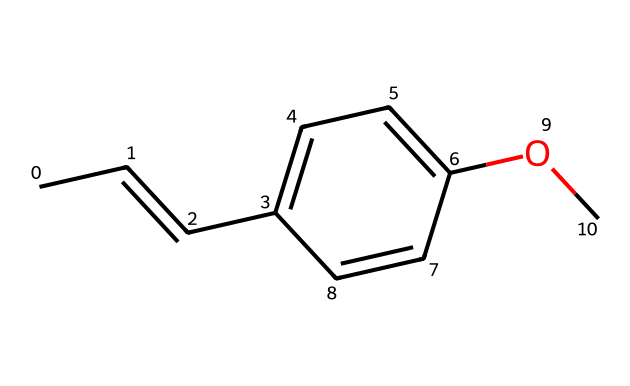What is the molecular formula of this compound? To determine the molecular formula, count the number of each type of atom in the structure. In this SMILES representation, there are 10 carbon atoms (C), 12 hydrogen atoms (H), and 1 oxygen atom (O). This gives the formula C10H12O.
Answer: C10H12O How many double bonds are present in this structure? Examine the SMILES; the "CC=CC" part indicates one double bond, and "C1=CC=C" presents two further double bonds in the ring. In total, there are three double bonds in the structure.
Answer: 3 Which type of isomerism is displayed in this compound? The presence of cis and trans configurations around the double bonds indicates geometric isomerism. The structure allows for these arrangements due to restricted rotation at the double bonds.
Answer: geometric isomerism How many rings are in the chemical structure? Review the structure indicated by the SMILES. The "C1=CC=C" is a cyclic (ring) component, meaning there is one ring present in this compound's structure.
Answer: 1 What type of functional group is present in this compound? The "OC" in the SMILES denotes an ether functional group, characterized by an oxygen atom connected to two carbon atoms. This indicates the presence of an ether.
Answer: ether What effect does the cis-trans isomerism have on the properties of incense compounds? The geometric arrangement (cis or trans) affects physical properties such as boiling point, melting point, and solubility, which can influence the scent profile of incense. The cis configuration often leads to stronger interaction with olfactory receptors.
Answer: scent profile 